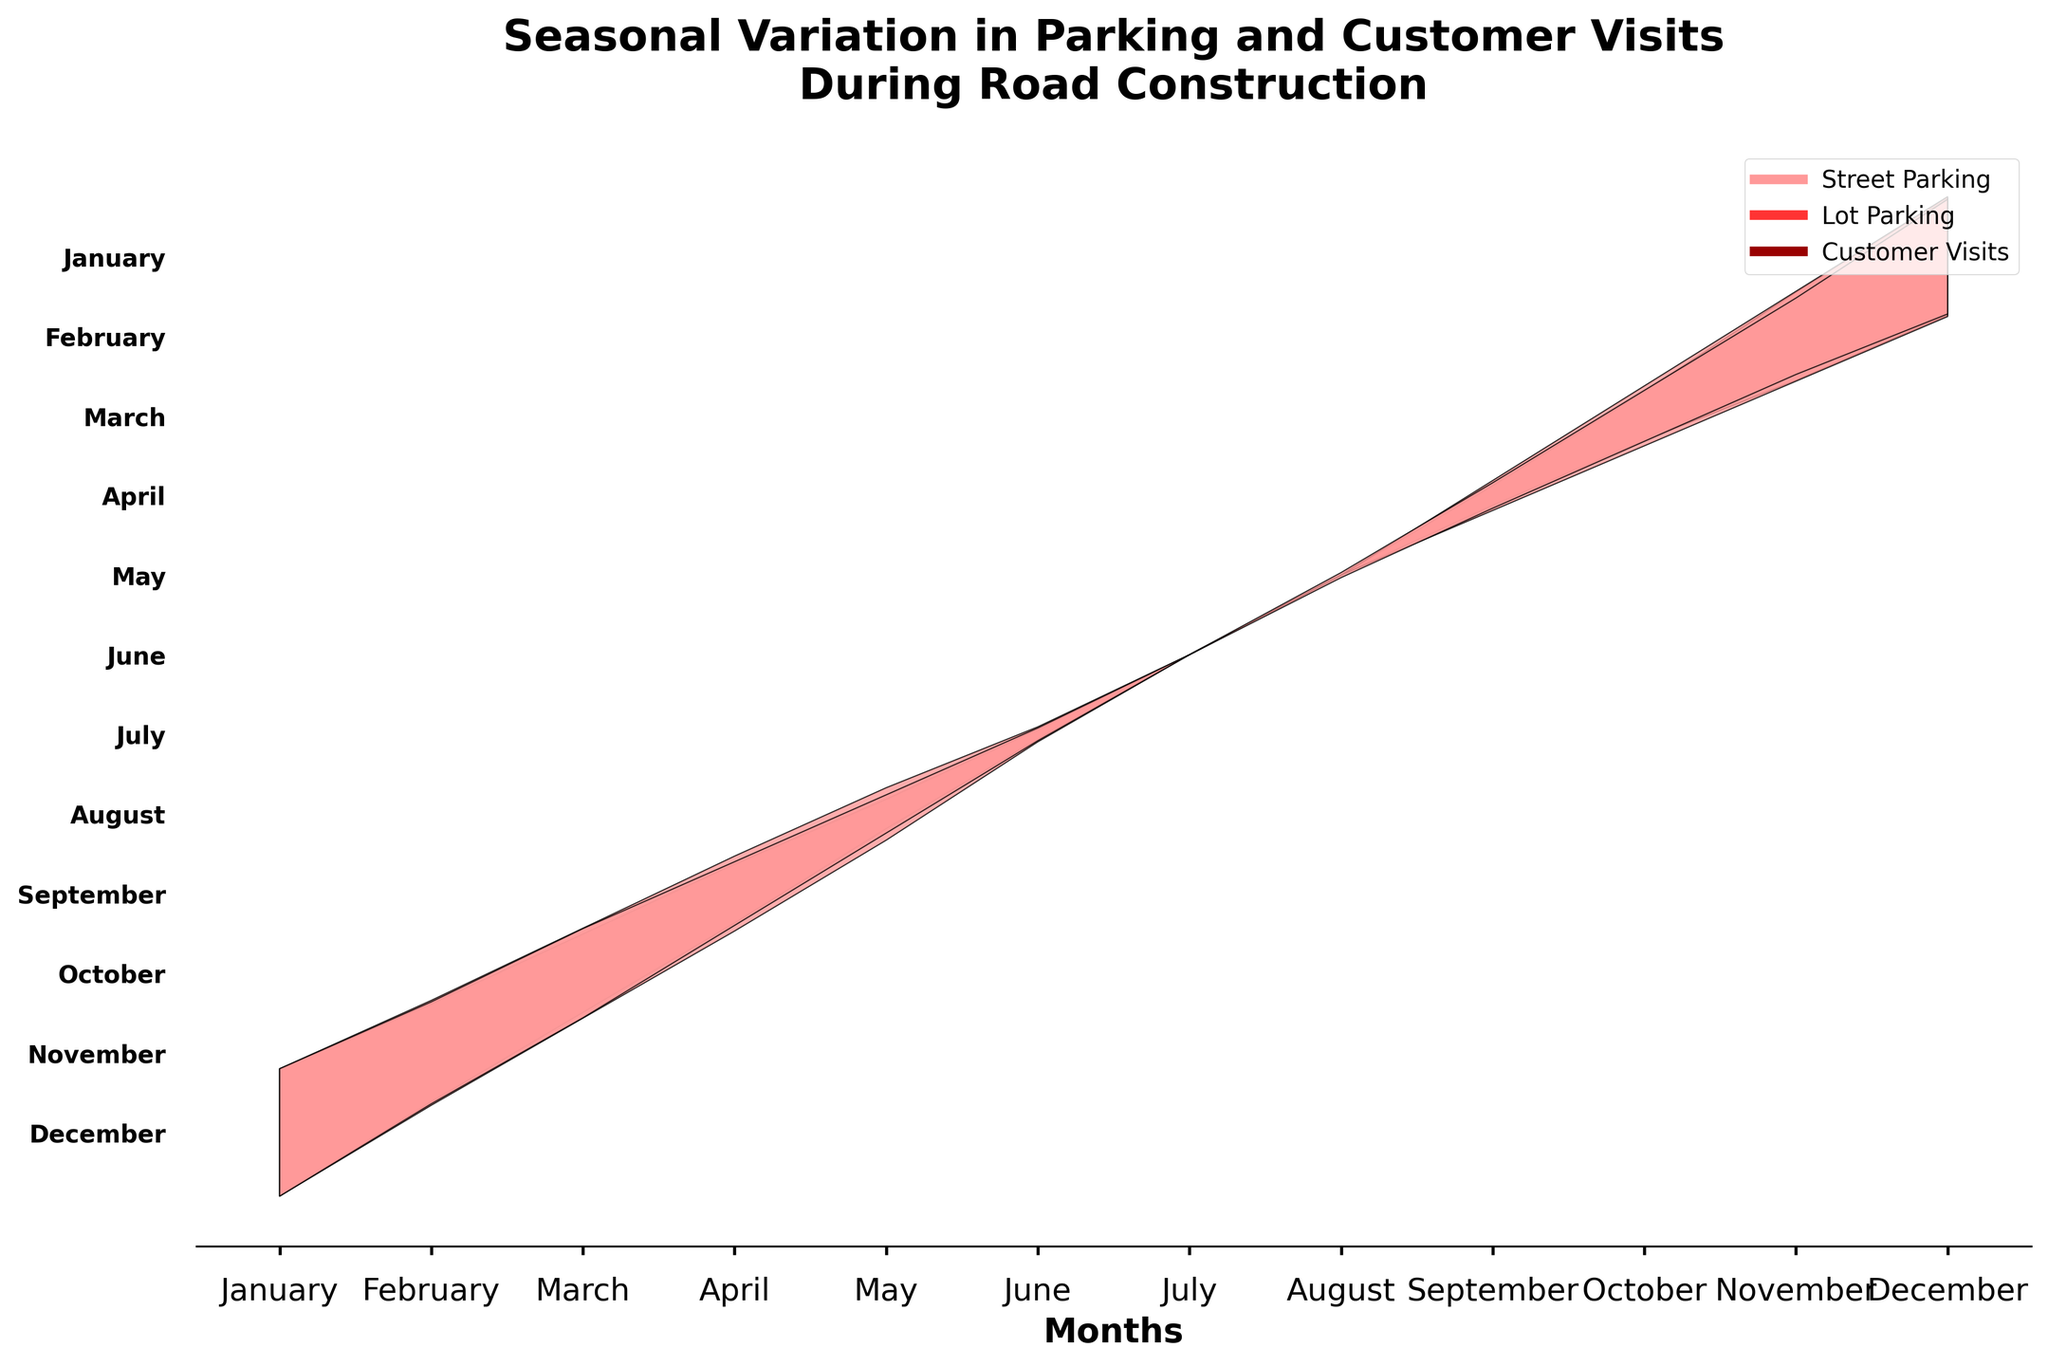What's the title of the figure? The title is prominently displayed at the top of the figure and describes the overall theme and topic of the plot.
Answer: Seasonal Variation in Parking and Customer Visits During Road Construction Which month sees the highest amount of street parking? By examining the filled areas corresponding to street parking across different months, we notice that January has the highest values since it has a wider shaded area compared to others.
Answer: January How do customer visits in July compare to August? By looking at the scaled values represented in different months, July has slightly lower values than August, indicated by slightly narrower shaded areas for July compared to August.
Answer: Slightly lower During which month is the difference between street parking and lot parking the smallest? Observing the plot, the month of August shows street and lot parking as having very similar scaled values, represented by nearly identical shaded areas.
Answer: August What is the trend of street parking availability from January to June? Street parking availability declines steadily from January through June, as indicated by the progressively narrower shaded areas over these months.
Answer: Steady decline In which months do customer visits increase compared to the previous months? By noting the variations in shaded areas, customer visits increase from July to August and also from September to October, marked by the expanded area in these months.
Answer: August, October Which parking option shows less seasonal variation? Comparing the variations of scaled shaded areas, lot parking has smaller Ranges and more consistent shaded areas indicating less seasonal variation compared to street parking.
Answer: Lot parking How does lot parking availability in November compare to October? The plot shows that the shaded areas representing lot parking in October and November are quite similar, but November has a slightly wider area, indicating a slight increase in lot parking compared to October.
Answer: Slight increase What is the primary insight about customer visits during summer months? Observing the plot, from June to August, customer visits are notably lower compared to other months, as indicated by the narrower shaded areas.
Answer: Lower in summer What is the relationship between street parking and customer visits across the year? Generally, customer visits tend to follow the trend set by street parking availability; for example, both decline from January through June and both increase towards the end of the year from September to December.
Answer: Similar trend 